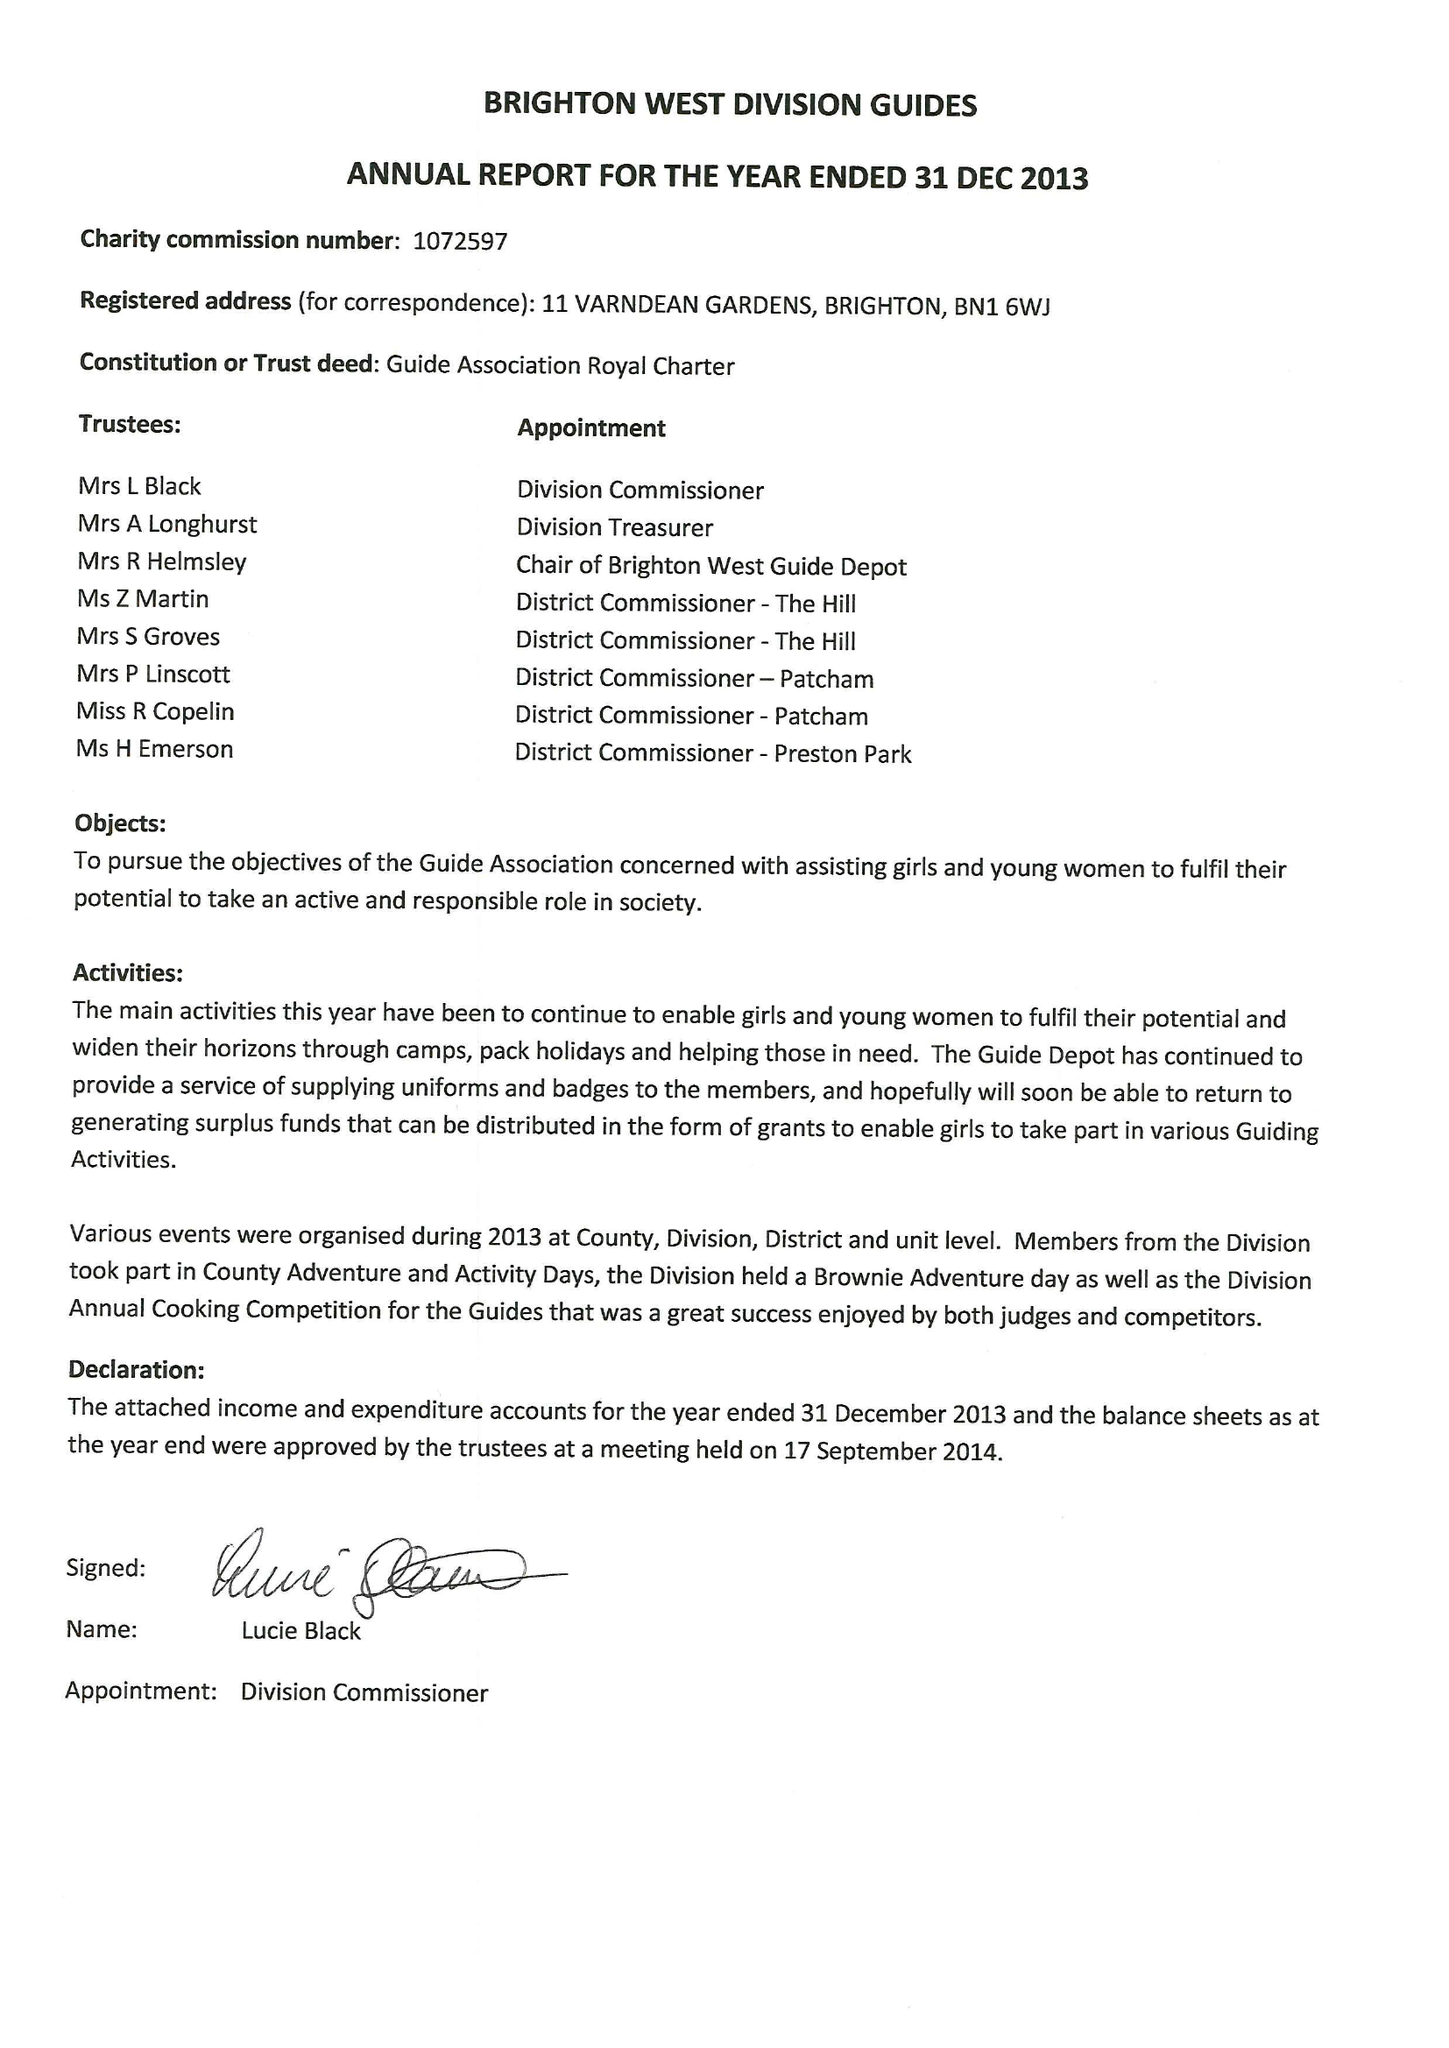What is the value for the charity_number?
Answer the question using a single word or phrase. 1072597 